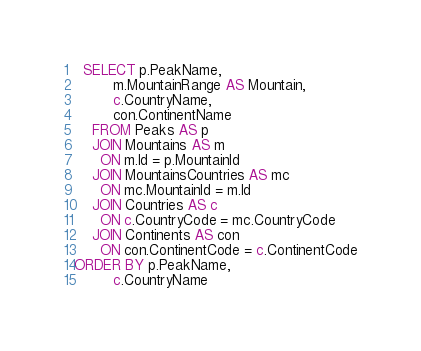<code> <loc_0><loc_0><loc_500><loc_500><_SQL_>  SELECT p.PeakName,
  	     m.MountainRange AS Mountain,
		 c.CountryName,
		 con.ContinentName
    FROM Peaks AS p
    JOIN Mountains AS m
      ON m.Id = p.MountainId
    JOIN MountainsCountries AS mc
      ON mc.MountainId = m.Id
    JOIN Countries AS c
      ON c.CountryCode = mc.CountryCode
    JOIN Continents AS con
      ON con.ContinentCode = c.ContinentCode
ORDER BY p.PeakName,
		 c.CountryName</code> 